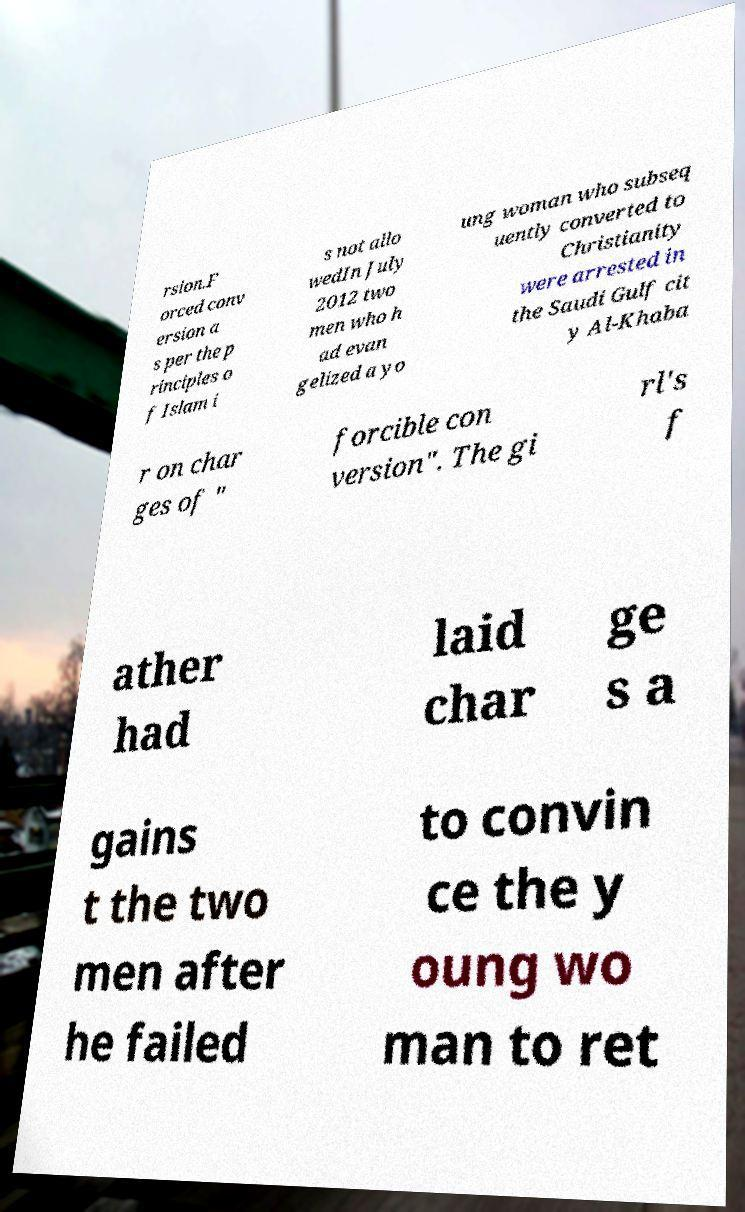Please identify and transcribe the text found in this image. rsion.F orced conv ersion a s per the p rinciples o f Islam i s not allo wedIn July 2012 two men who h ad evan gelized a yo ung woman who subseq uently converted to Christianity were arrested in the Saudi Gulf cit y Al-Khaba r on char ges of " forcible con version". The gi rl's f ather had laid char ge s a gains t the two men after he failed to convin ce the y oung wo man to ret 